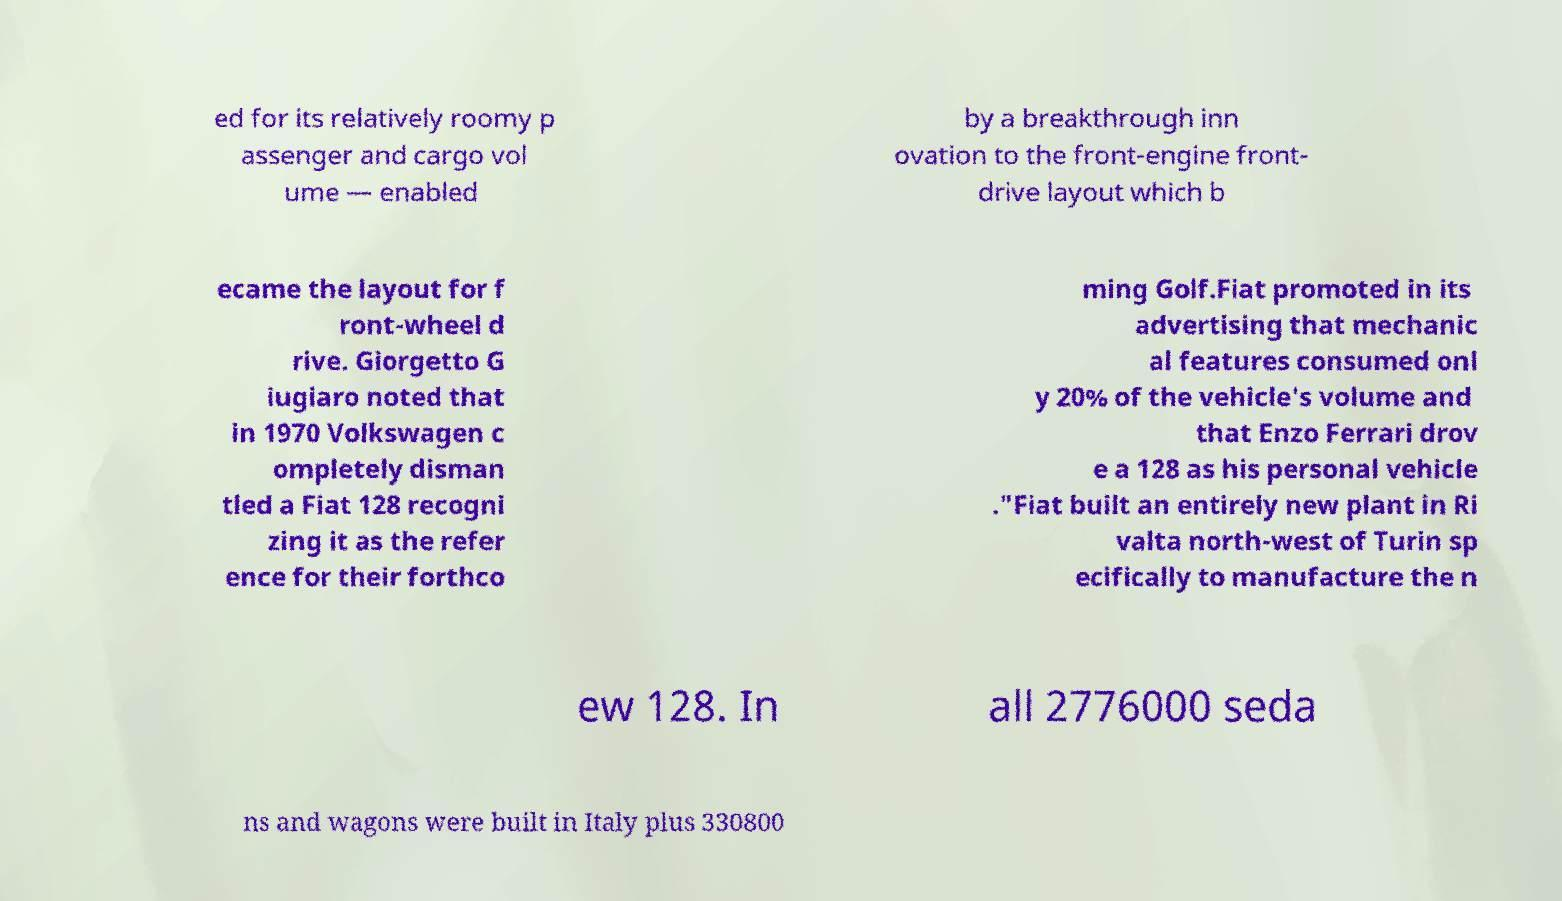What messages or text are displayed in this image? I need them in a readable, typed format. ed for its relatively roomy p assenger and cargo vol ume — enabled by a breakthrough inn ovation to the front-engine front- drive layout which b ecame the layout for f ront-wheel d rive. Giorgetto G iugiaro noted that in 1970 Volkswagen c ompletely disman tled a Fiat 128 recogni zing it as the refer ence for their forthco ming Golf.Fiat promoted in its advertising that mechanic al features consumed onl y 20% of the vehicle's volume and that Enzo Ferrari drov e a 128 as his personal vehicle ."Fiat built an entirely new plant in Ri valta north-west of Turin sp ecifically to manufacture the n ew 128. In all 2776000 seda ns and wagons were built in Italy plus 330800 